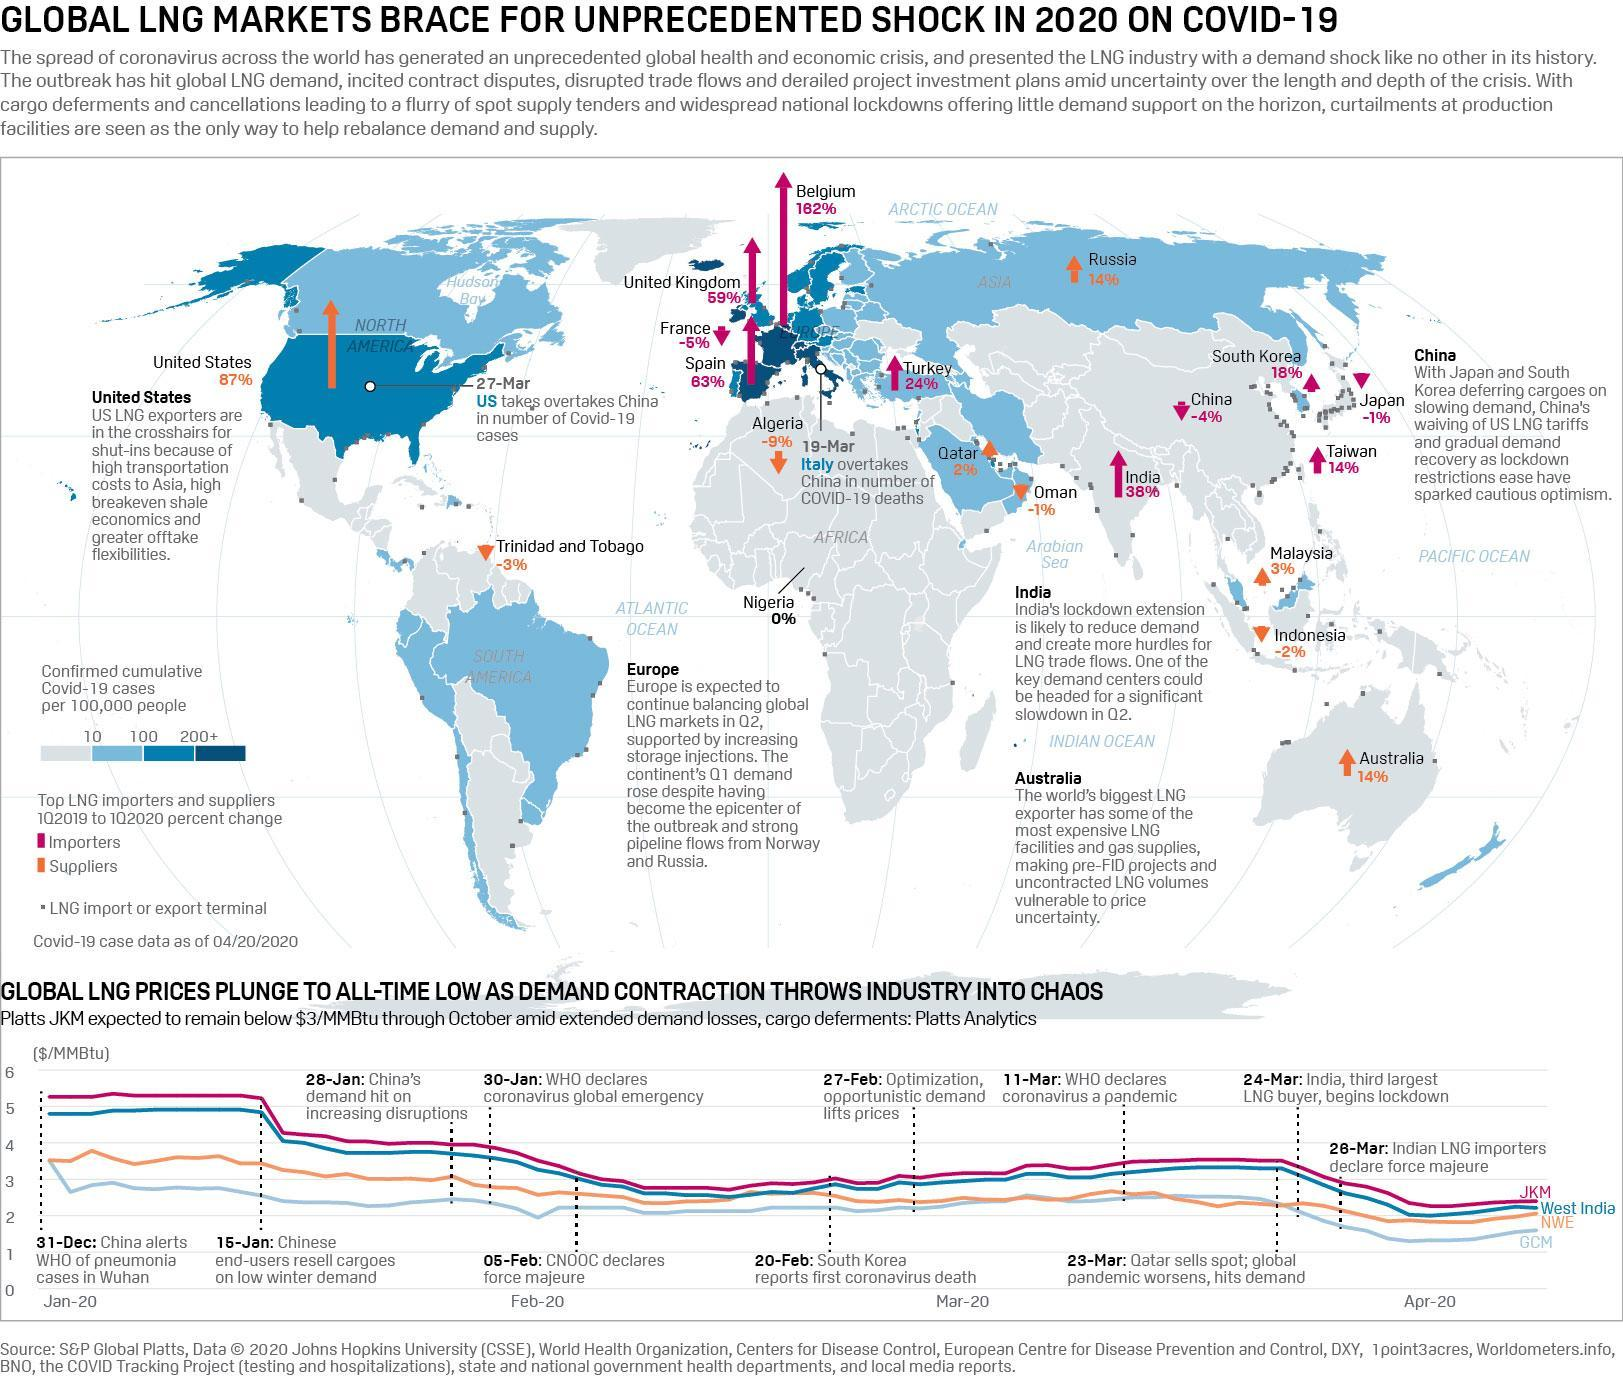On which day WHO declared Covid 19 global emergency?
Answer the question with a short phrase. 30-Jan When did WHO declared Corona virus a pandemic? 11-Mar 